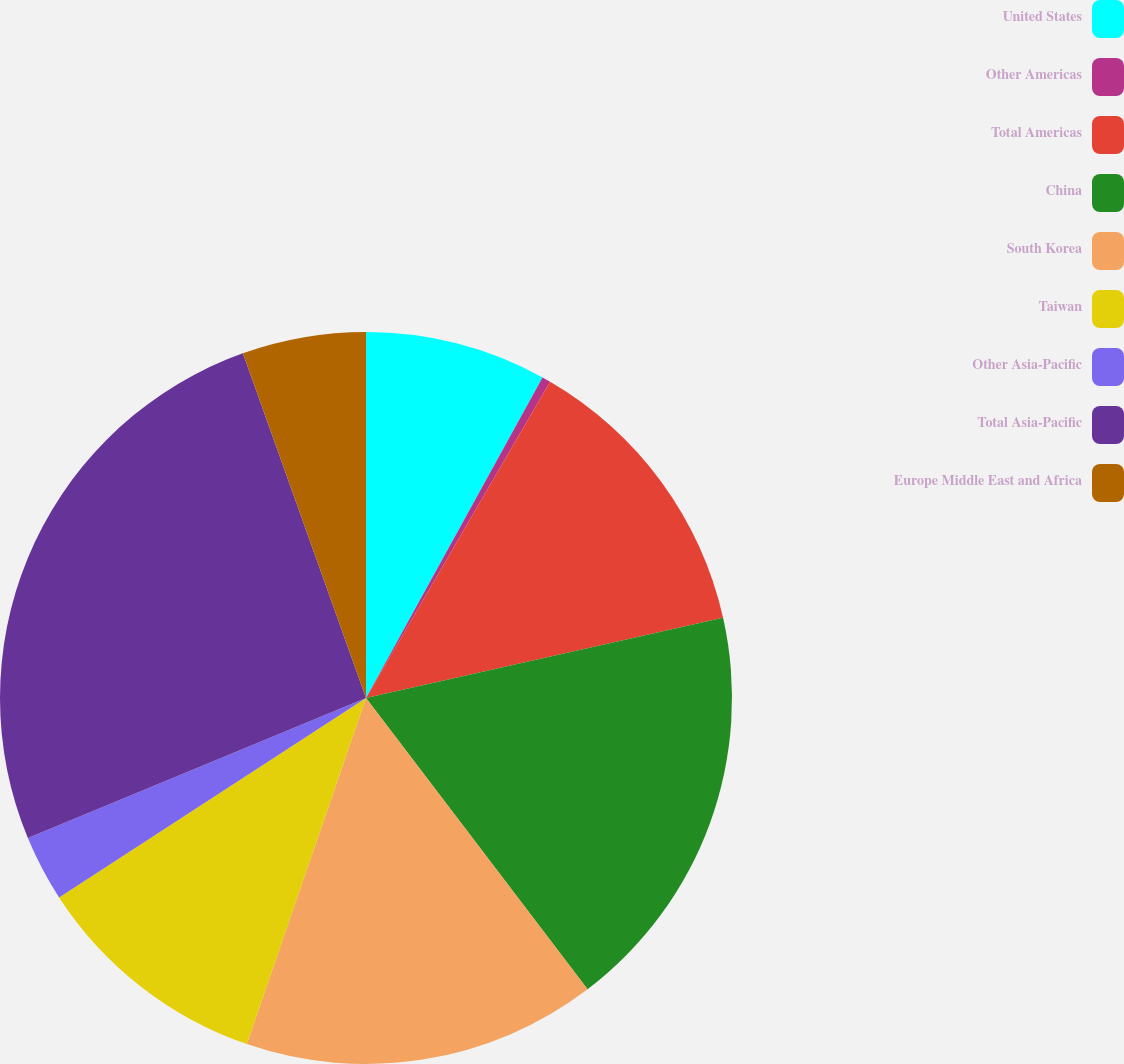Convert chart. <chart><loc_0><loc_0><loc_500><loc_500><pie_chart><fcel>United States<fcel>Other Americas<fcel>Total Americas<fcel>China<fcel>South Korea<fcel>Taiwan<fcel>Other Asia-Pacific<fcel>Total Asia-Pacific<fcel>Europe Middle East and Africa<nl><fcel>8.01%<fcel>0.38%<fcel>13.09%<fcel>18.17%<fcel>15.63%<fcel>10.55%<fcel>2.92%<fcel>25.79%<fcel>5.46%<nl></chart> 